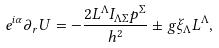Convert formula to latex. <formula><loc_0><loc_0><loc_500><loc_500>e ^ { i \alpha } \partial _ { r } U = - \frac { 2 L ^ { \Lambda } I _ { \Lambda \Sigma } p ^ { \Sigma } } { h ^ { 2 } } \pm g \xi _ { \Lambda } L ^ { \Lambda } ,</formula> 